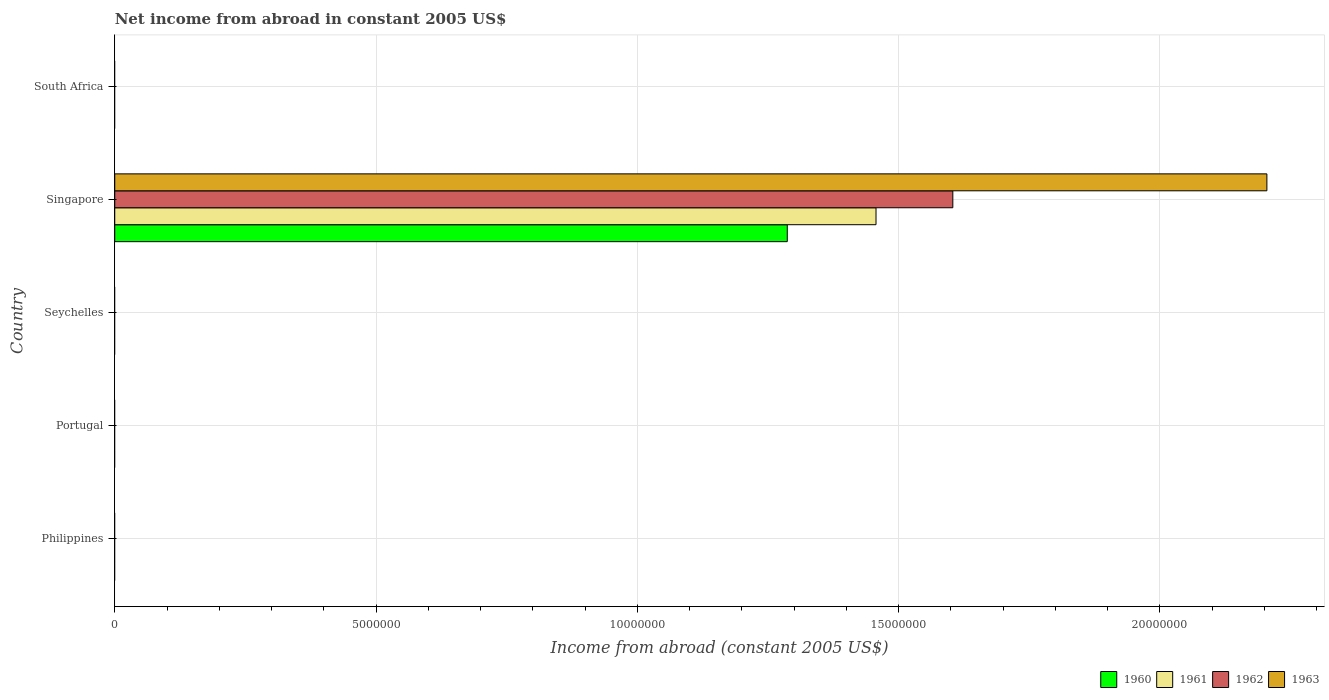Are the number of bars per tick equal to the number of legend labels?
Offer a terse response. No. Are the number of bars on each tick of the Y-axis equal?
Your response must be concise. No. How many bars are there on the 1st tick from the top?
Your response must be concise. 0. How many bars are there on the 5th tick from the bottom?
Provide a short and direct response. 0. What is the label of the 1st group of bars from the top?
Offer a very short reply. South Africa. Across all countries, what is the maximum net income from abroad in 1962?
Offer a terse response. 1.60e+07. In which country was the net income from abroad in 1960 maximum?
Ensure brevity in your answer.  Singapore. What is the total net income from abroad in 1961 in the graph?
Your response must be concise. 1.46e+07. What is the difference between the net income from abroad in 1962 in Seychelles and the net income from abroad in 1963 in Singapore?
Offer a terse response. -2.20e+07. What is the average net income from abroad in 1960 per country?
Your answer should be compact. 2.57e+06. What is the difference between the net income from abroad in 1961 and net income from abroad in 1960 in Singapore?
Keep it short and to the point. 1.70e+06. In how many countries, is the net income from abroad in 1961 greater than 2000000 US$?
Provide a succinct answer. 1. What is the difference between the highest and the lowest net income from abroad in 1960?
Offer a very short reply. 1.29e+07. How many bars are there?
Make the answer very short. 4. Are the values on the major ticks of X-axis written in scientific E-notation?
Give a very brief answer. No. Does the graph contain any zero values?
Your answer should be compact. Yes. What is the title of the graph?
Keep it short and to the point. Net income from abroad in constant 2005 US$. What is the label or title of the X-axis?
Ensure brevity in your answer.  Income from abroad (constant 2005 US$). What is the label or title of the Y-axis?
Provide a succinct answer. Country. What is the Income from abroad (constant 2005 US$) in 1961 in Philippines?
Your answer should be very brief. 0. What is the Income from abroad (constant 2005 US$) of 1962 in Philippines?
Provide a succinct answer. 0. What is the Income from abroad (constant 2005 US$) of 1961 in Portugal?
Ensure brevity in your answer.  0. What is the Income from abroad (constant 2005 US$) of 1962 in Portugal?
Your response must be concise. 0. What is the Income from abroad (constant 2005 US$) in 1963 in Portugal?
Keep it short and to the point. 0. What is the Income from abroad (constant 2005 US$) in 1963 in Seychelles?
Give a very brief answer. 0. What is the Income from abroad (constant 2005 US$) of 1960 in Singapore?
Ensure brevity in your answer.  1.29e+07. What is the Income from abroad (constant 2005 US$) of 1961 in Singapore?
Your response must be concise. 1.46e+07. What is the Income from abroad (constant 2005 US$) in 1962 in Singapore?
Provide a succinct answer. 1.60e+07. What is the Income from abroad (constant 2005 US$) in 1963 in Singapore?
Make the answer very short. 2.20e+07. Across all countries, what is the maximum Income from abroad (constant 2005 US$) of 1960?
Make the answer very short. 1.29e+07. Across all countries, what is the maximum Income from abroad (constant 2005 US$) in 1961?
Ensure brevity in your answer.  1.46e+07. Across all countries, what is the maximum Income from abroad (constant 2005 US$) of 1962?
Make the answer very short. 1.60e+07. Across all countries, what is the maximum Income from abroad (constant 2005 US$) of 1963?
Your response must be concise. 2.20e+07. Across all countries, what is the minimum Income from abroad (constant 2005 US$) of 1960?
Make the answer very short. 0. Across all countries, what is the minimum Income from abroad (constant 2005 US$) in 1962?
Offer a very short reply. 0. What is the total Income from abroad (constant 2005 US$) in 1960 in the graph?
Provide a succinct answer. 1.29e+07. What is the total Income from abroad (constant 2005 US$) in 1961 in the graph?
Your response must be concise. 1.46e+07. What is the total Income from abroad (constant 2005 US$) of 1962 in the graph?
Offer a very short reply. 1.60e+07. What is the total Income from abroad (constant 2005 US$) of 1963 in the graph?
Ensure brevity in your answer.  2.20e+07. What is the average Income from abroad (constant 2005 US$) of 1960 per country?
Keep it short and to the point. 2.57e+06. What is the average Income from abroad (constant 2005 US$) of 1961 per country?
Offer a very short reply. 2.91e+06. What is the average Income from abroad (constant 2005 US$) of 1962 per country?
Your answer should be very brief. 3.21e+06. What is the average Income from abroad (constant 2005 US$) in 1963 per country?
Make the answer very short. 4.41e+06. What is the difference between the Income from abroad (constant 2005 US$) of 1960 and Income from abroad (constant 2005 US$) of 1961 in Singapore?
Make the answer very short. -1.70e+06. What is the difference between the Income from abroad (constant 2005 US$) of 1960 and Income from abroad (constant 2005 US$) of 1962 in Singapore?
Keep it short and to the point. -3.17e+06. What is the difference between the Income from abroad (constant 2005 US$) in 1960 and Income from abroad (constant 2005 US$) in 1963 in Singapore?
Give a very brief answer. -9.18e+06. What is the difference between the Income from abroad (constant 2005 US$) of 1961 and Income from abroad (constant 2005 US$) of 1962 in Singapore?
Give a very brief answer. -1.47e+06. What is the difference between the Income from abroad (constant 2005 US$) of 1961 and Income from abroad (constant 2005 US$) of 1963 in Singapore?
Give a very brief answer. -7.48e+06. What is the difference between the Income from abroad (constant 2005 US$) in 1962 and Income from abroad (constant 2005 US$) in 1963 in Singapore?
Give a very brief answer. -6.01e+06. What is the difference between the highest and the lowest Income from abroad (constant 2005 US$) of 1960?
Your answer should be compact. 1.29e+07. What is the difference between the highest and the lowest Income from abroad (constant 2005 US$) in 1961?
Your response must be concise. 1.46e+07. What is the difference between the highest and the lowest Income from abroad (constant 2005 US$) in 1962?
Offer a terse response. 1.60e+07. What is the difference between the highest and the lowest Income from abroad (constant 2005 US$) in 1963?
Make the answer very short. 2.20e+07. 